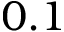<formula> <loc_0><loc_0><loc_500><loc_500>0 . 1</formula> 